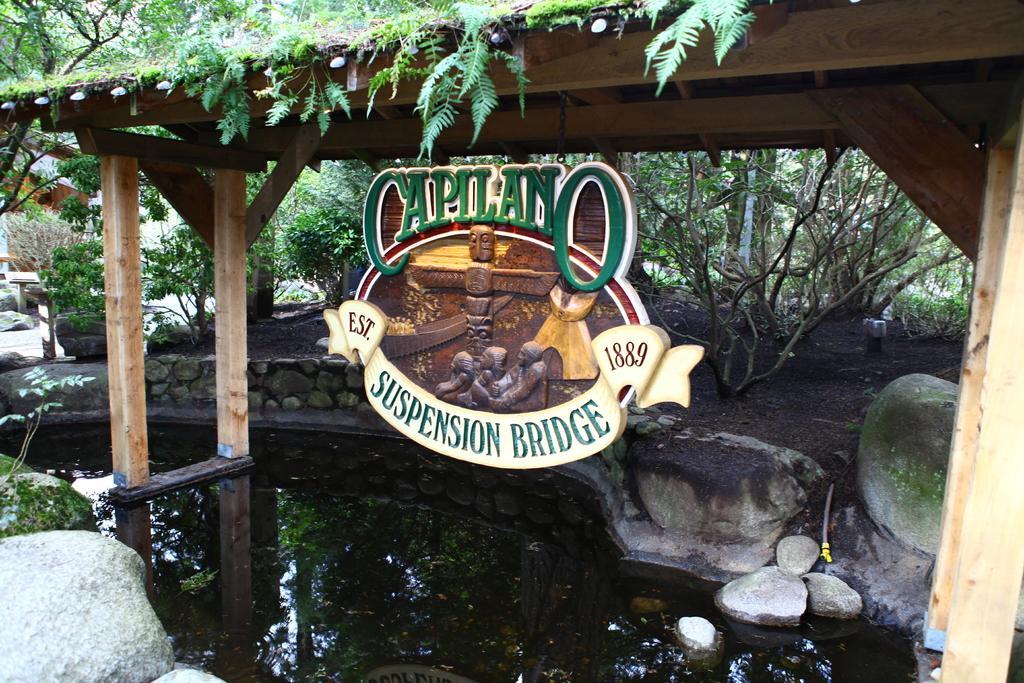Could you give a brief overview of what you see in this image? This picture is clicked outside. In the foreground we can see a water body and some rocks. In the center we can see a wooden tent and we can see the text and pictures of persons and the pictures of some objects on the poster hanging on the tent. In the background we can see the trees, plants, rocks and some other objects. 